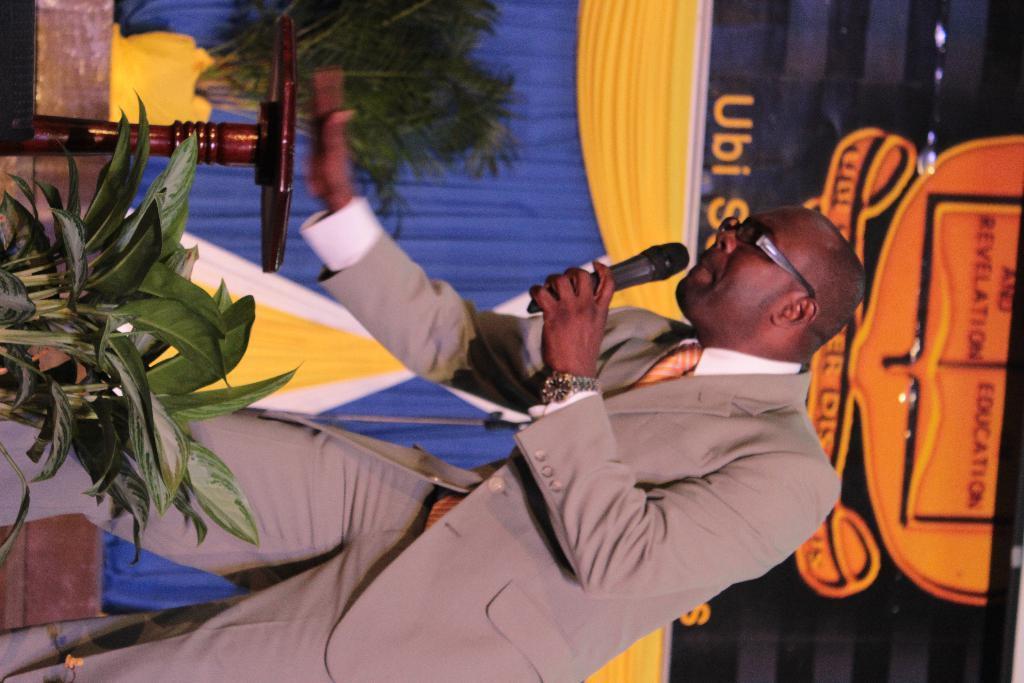How would you summarize this image in a sentence or two? In the image there is a plant in the foreground, behind the plant there is a man and in front of the man there is a table and in the background there are curtains, a plant and above the curtains there is some logo. 